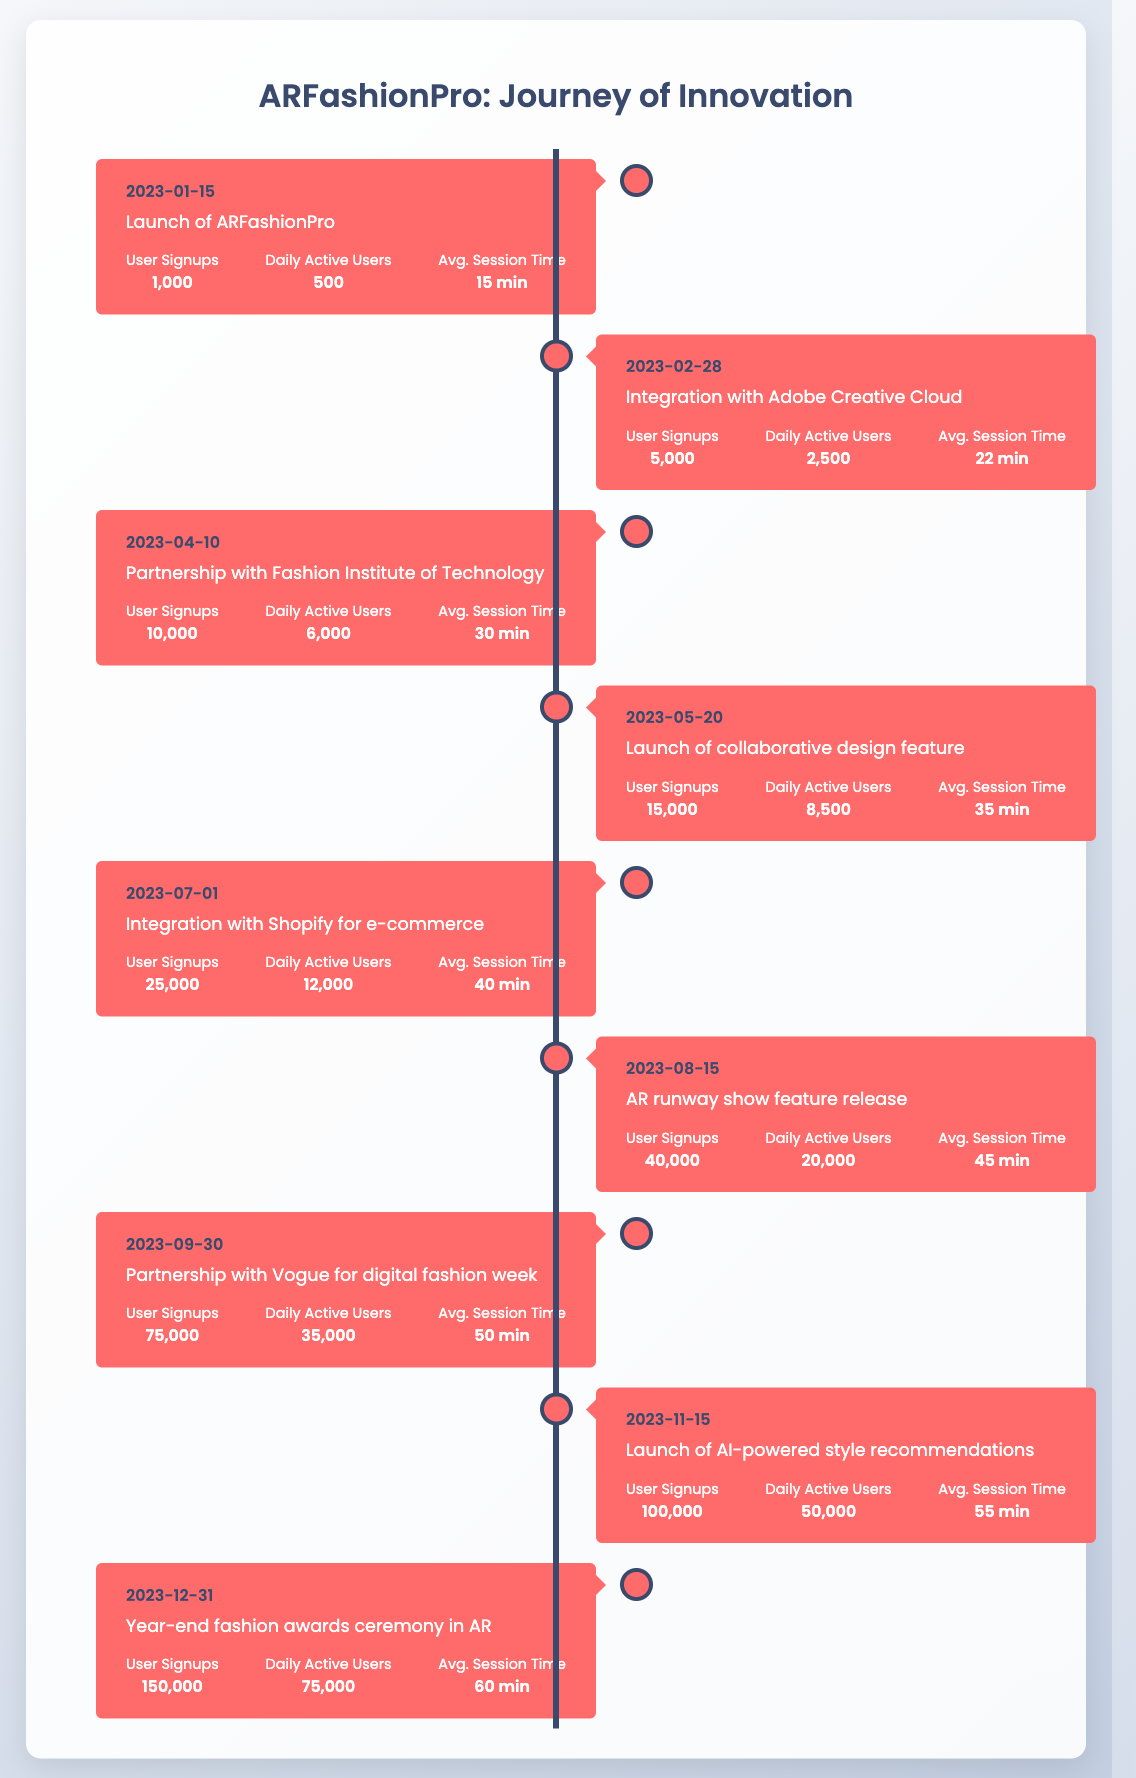What was the average session time on the launch date of ARFashionPro? The average session time on the launch date, January 15, 2023, is provided directly in the table. It states "15 minutes" under the "Avg. Session Time" column.
Answer: 15 minutes What was the peak number of daily active users? The peak number of daily active users is identified by inspecting the "Daily Active Users" column. The maximum value appears on December 31, 2023, with "75,000."
Answer: 75,000 Did the average session time increase with each major event? To determine this, we can compare the average session times across significant events from January to December. Starting at 15 minutes and progressively increasing, we see the values are: 15, 22, 30, 35, 40, 45, 50, 55, and 60 minutes. Thus, it shows a consistent increase.
Answer: Yes What is the total number of user signups from the launch till the end of the year? We sum the user signups for each entry: 1,000 + 5,000 + 10,000 + 15,000 + 25,000 + 40,000 + 75,000 + 100,000 + 150,000 = 421,000. This provides the total user signups for the 2023 timeline.
Answer: 421,000 How many user signups were achieved from the integration with Adobe Creative Cloud to the AR runway show feature release? We take the user signups from February 28 to August 15, which are: 5,000 (Feb) + 10,000 (Apr) + 15,000 (May) + 25,000 (Jul) + 40,000 (Aug) = 95,000. Therefore, this represents the cumulative signups in this period.
Answer: 95,000 What was the increase in daily active users from the launch to the end of the year? The number of daily active users at launch is 500, and by December 31, it increased to 75,000. The difference is calculated: 75,000 - 500 = 74,500. Thus, the increase is substantial.
Answer: 74,500 Which event had the highest number of user signups? Upon reviewing the user signups across all events, December 31, 2023, had the highest value at "150,000" signups, which exceeds all other entries.
Answer: 150,000 Was there a notable drop in daily active users after any event? By comparing daily active users before and after major events, there are no examples of drops; every major event either maintains or increases user engagement from the previous numbers listed.
Answer: No 